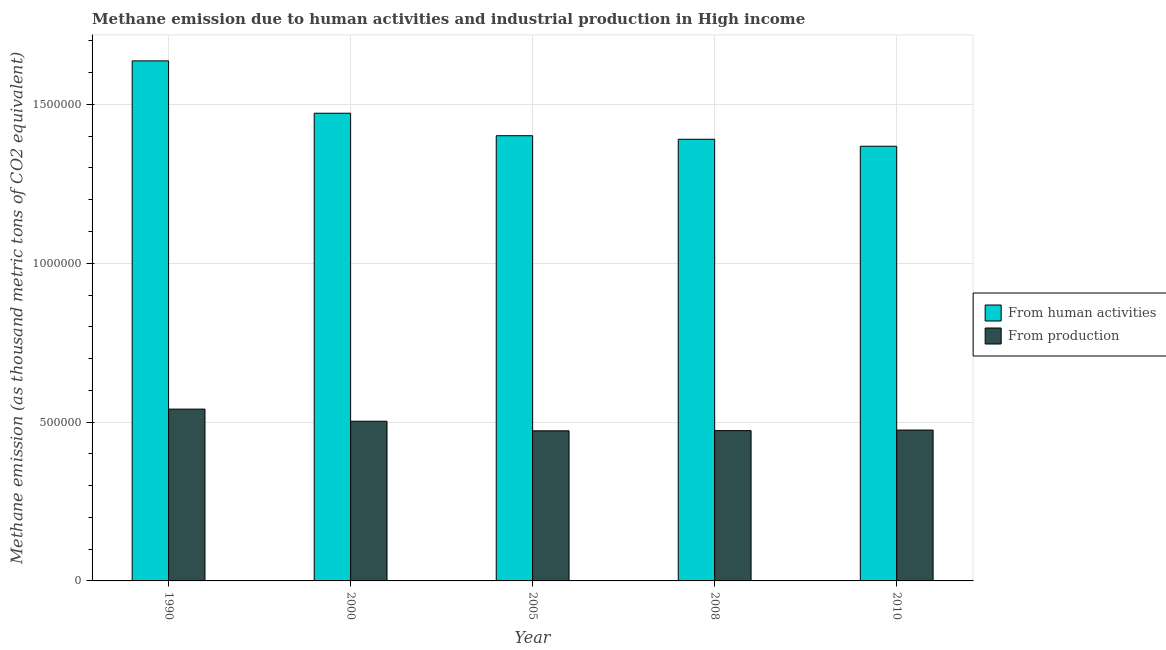How many different coloured bars are there?
Your answer should be very brief. 2. How many bars are there on the 5th tick from the left?
Offer a very short reply. 2. How many bars are there on the 2nd tick from the right?
Provide a succinct answer. 2. What is the amount of emissions generated from industries in 2010?
Keep it short and to the point. 4.75e+05. Across all years, what is the maximum amount of emissions generated from industries?
Give a very brief answer. 5.41e+05. Across all years, what is the minimum amount of emissions generated from industries?
Provide a succinct answer. 4.73e+05. In which year was the amount of emissions from human activities maximum?
Ensure brevity in your answer.  1990. What is the total amount of emissions from human activities in the graph?
Your answer should be compact. 7.27e+06. What is the difference between the amount of emissions from human activities in 2005 and that in 2010?
Your answer should be compact. 3.32e+04. What is the difference between the amount of emissions from human activities in 2005 and the amount of emissions generated from industries in 2008?
Ensure brevity in your answer.  1.12e+04. What is the average amount of emissions from human activities per year?
Give a very brief answer. 1.45e+06. In the year 2000, what is the difference between the amount of emissions generated from industries and amount of emissions from human activities?
Ensure brevity in your answer.  0. In how many years, is the amount of emissions from human activities greater than 300000 thousand metric tons?
Offer a terse response. 5. What is the ratio of the amount of emissions generated from industries in 1990 to that in 2000?
Make the answer very short. 1.08. Is the amount of emissions generated from industries in 1990 less than that in 2000?
Your response must be concise. No. What is the difference between the highest and the second highest amount of emissions generated from industries?
Provide a succinct answer. 3.82e+04. What is the difference between the highest and the lowest amount of emissions from human activities?
Your answer should be compact. 2.69e+05. In how many years, is the amount of emissions from human activities greater than the average amount of emissions from human activities taken over all years?
Give a very brief answer. 2. Is the sum of the amount of emissions from human activities in 2000 and 2008 greater than the maximum amount of emissions generated from industries across all years?
Your answer should be compact. Yes. What does the 2nd bar from the left in 2005 represents?
Offer a very short reply. From production. What does the 2nd bar from the right in 2005 represents?
Give a very brief answer. From human activities. How many bars are there?
Provide a short and direct response. 10. How many years are there in the graph?
Provide a short and direct response. 5. Are the values on the major ticks of Y-axis written in scientific E-notation?
Your answer should be compact. No. Does the graph contain grids?
Make the answer very short. Yes. Where does the legend appear in the graph?
Keep it short and to the point. Center right. How many legend labels are there?
Your response must be concise. 2. What is the title of the graph?
Offer a very short reply. Methane emission due to human activities and industrial production in High income. What is the label or title of the Y-axis?
Your response must be concise. Methane emission (as thousand metric tons of CO2 equivalent). What is the Methane emission (as thousand metric tons of CO2 equivalent) of From human activities in 1990?
Offer a terse response. 1.64e+06. What is the Methane emission (as thousand metric tons of CO2 equivalent) in From production in 1990?
Keep it short and to the point. 5.41e+05. What is the Methane emission (as thousand metric tons of CO2 equivalent) of From human activities in 2000?
Keep it short and to the point. 1.47e+06. What is the Methane emission (as thousand metric tons of CO2 equivalent) in From production in 2000?
Ensure brevity in your answer.  5.03e+05. What is the Methane emission (as thousand metric tons of CO2 equivalent) in From human activities in 2005?
Your response must be concise. 1.40e+06. What is the Methane emission (as thousand metric tons of CO2 equivalent) in From production in 2005?
Provide a short and direct response. 4.73e+05. What is the Methane emission (as thousand metric tons of CO2 equivalent) in From human activities in 2008?
Ensure brevity in your answer.  1.39e+06. What is the Methane emission (as thousand metric tons of CO2 equivalent) of From production in 2008?
Make the answer very short. 4.73e+05. What is the Methane emission (as thousand metric tons of CO2 equivalent) of From human activities in 2010?
Keep it short and to the point. 1.37e+06. What is the Methane emission (as thousand metric tons of CO2 equivalent) of From production in 2010?
Your answer should be very brief. 4.75e+05. Across all years, what is the maximum Methane emission (as thousand metric tons of CO2 equivalent) in From human activities?
Keep it short and to the point. 1.64e+06. Across all years, what is the maximum Methane emission (as thousand metric tons of CO2 equivalent) of From production?
Offer a terse response. 5.41e+05. Across all years, what is the minimum Methane emission (as thousand metric tons of CO2 equivalent) in From human activities?
Keep it short and to the point. 1.37e+06. Across all years, what is the minimum Methane emission (as thousand metric tons of CO2 equivalent) of From production?
Your answer should be compact. 4.73e+05. What is the total Methane emission (as thousand metric tons of CO2 equivalent) in From human activities in the graph?
Give a very brief answer. 7.27e+06. What is the total Methane emission (as thousand metric tons of CO2 equivalent) in From production in the graph?
Offer a terse response. 2.46e+06. What is the difference between the Methane emission (as thousand metric tons of CO2 equivalent) in From human activities in 1990 and that in 2000?
Make the answer very short. 1.65e+05. What is the difference between the Methane emission (as thousand metric tons of CO2 equivalent) in From production in 1990 and that in 2000?
Offer a very short reply. 3.82e+04. What is the difference between the Methane emission (as thousand metric tons of CO2 equivalent) of From human activities in 1990 and that in 2005?
Offer a very short reply. 2.36e+05. What is the difference between the Methane emission (as thousand metric tons of CO2 equivalent) of From production in 1990 and that in 2005?
Ensure brevity in your answer.  6.83e+04. What is the difference between the Methane emission (as thousand metric tons of CO2 equivalent) in From human activities in 1990 and that in 2008?
Provide a succinct answer. 2.47e+05. What is the difference between the Methane emission (as thousand metric tons of CO2 equivalent) in From production in 1990 and that in 2008?
Offer a terse response. 6.77e+04. What is the difference between the Methane emission (as thousand metric tons of CO2 equivalent) in From human activities in 1990 and that in 2010?
Provide a short and direct response. 2.69e+05. What is the difference between the Methane emission (as thousand metric tons of CO2 equivalent) in From production in 1990 and that in 2010?
Your answer should be compact. 6.59e+04. What is the difference between the Methane emission (as thousand metric tons of CO2 equivalent) of From human activities in 2000 and that in 2005?
Give a very brief answer. 7.08e+04. What is the difference between the Methane emission (as thousand metric tons of CO2 equivalent) of From production in 2000 and that in 2005?
Your answer should be compact. 3.02e+04. What is the difference between the Methane emission (as thousand metric tons of CO2 equivalent) of From human activities in 2000 and that in 2008?
Your response must be concise. 8.20e+04. What is the difference between the Methane emission (as thousand metric tons of CO2 equivalent) in From production in 2000 and that in 2008?
Provide a short and direct response. 2.96e+04. What is the difference between the Methane emission (as thousand metric tons of CO2 equivalent) of From human activities in 2000 and that in 2010?
Your answer should be very brief. 1.04e+05. What is the difference between the Methane emission (as thousand metric tons of CO2 equivalent) of From production in 2000 and that in 2010?
Your response must be concise. 2.78e+04. What is the difference between the Methane emission (as thousand metric tons of CO2 equivalent) in From human activities in 2005 and that in 2008?
Give a very brief answer. 1.12e+04. What is the difference between the Methane emission (as thousand metric tons of CO2 equivalent) in From production in 2005 and that in 2008?
Offer a terse response. -593. What is the difference between the Methane emission (as thousand metric tons of CO2 equivalent) of From human activities in 2005 and that in 2010?
Your answer should be very brief. 3.32e+04. What is the difference between the Methane emission (as thousand metric tons of CO2 equivalent) of From production in 2005 and that in 2010?
Give a very brief answer. -2407.6. What is the difference between the Methane emission (as thousand metric tons of CO2 equivalent) in From human activities in 2008 and that in 2010?
Provide a short and direct response. 2.20e+04. What is the difference between the Methane emission (as thousand metric tons of CO2 equivalent) in From production in 2008 and that in 2010?
Give a very brief answer. -1814.6. What is the difference between the Methane emission (as thousand metric tons of CO2 equivalent) of From human activities in 1990 and the Methane emission (as thousand metric tons of CO2 equivalent) of From production in 2000?
Offer a very short reply. 1.13e+06. What is the difference between the Methane emission (as thousand metric tons of CO2 equivalent) in From human activities in 1990 and the Methane emission (as thousand metric tons of CO2 equivalent) in From production in 2005?
Your response must be concise. 1.16e+06. What is the difference between the Methane emission (as thousand metric tons of CO2 equivalent) in From human activities in 1990 and the Methane emission (as thousand metric tons of CO2 equivalent) in From production in 2008?
Offer a terse response. 1.16e+06. What is the difference between the Methane emission (as thousand metric tons of CO2 equivalent) in From human activities in 1990 and the Methane emission (as thousand metric tons of CO2 equivalent) in From production in 2010?
Your response must be concise. 1.16e+06. What is the difference between the Methane emission (as thousand metric tons of CO2 equivalent) of From human activities in 2000 and the Methane emission (as thousand metric tons of CO2 equivalent) of From production in 2005?
Keep it short and to the point. 1.00e+06. What is the difference between the Methane emission (as thousand metric tons of CO2 equivalent) of From human activities in 2000 and the Methane emission (as thousand metric tons of CO2 equivalent) of From production in 2008?
Ensure brevity in your answer.  9.99e+05. What is the difference between the Methane emission (as thousand metric tons of CO2 equivalent) of From human activities in 2000 and the Methane emission (as thousand metric tons of CO2 equivalent) of From production in 2010?
Your answer should be very brief. 9.97e+05. What is the difference between the Methane emission (as thousand metric tons of CO2 equivalent) in From human activities in 2005 and the Methane emission (as thousand metric tons of CO2 equivalent) in From production in 2008?
Keep it short and to the point. 9.28e+05. What is the difference between the Methane emission (as thousand metric tons of CO2 equivalent) of From human activities in 2005 and the Methane emission (as thousand metric tons of CO2 equivalent) of From production in 2010?
Make the answer very short. 9.27e+05. What is the difference between the Methane emission (as thousand metric tons of CO2 equivalent) of From human activities in 2008 and the Methane emission (as thousand metric tons of CO2 equivalent) of From production in 2010?
Your response must be concise. 9.15e+05. What is the average Methane emission (as thousand metric tons of CO2 equivalent) of From human activities per year?
Provide a succinct answer. 1.45e+06. What is the average Methane emission (as thousand metric tons of CO2 equivalent) in From production per year?
Give a very brief answer. 4.93e+05. In the year 1990, what is the difference between the Methane emission (as thousand metric tons of CO2 equivalent) in From human activities and Methane emission (as thousand metric tons of CO2 equivalent) in From production?
Provide a succinct answer. 1.10e+06. In the year 2000, what is the difference between the Methane emission (as thousand metric tons of CO2 equivalent) in From human activities and Methane emission (as thousand metric tons of CO2 equivalent) in From production?
Your response must be concise. 9.70e+05. In the year 2005, what is the difference between the Methane emission (as thousand metric tons of CO2 equivalent) in From human activities and Methane emission (as thousand metric tons of CO2 equivalent) in From production?
Offer a terse response. 9.29e+05. In the year 2008, what is the difference between the Methane emission (as thousand metric tons of CO2 equivalent) of From human activities and Methane emission (as thousand metric tons of CO2 equivalent) of From production?
Offer a terse response. 9.17e+05. In the year 2010, what is the difference between the Methane emission (as thousand metric tons of CO2 equivalent) in From human activities and Methane emission (as thousand metric tons of CO2 equivalent) in From production?
Provide a succinct answer. 8.93e+05. What is the ratio of the Methane emission (as thousand metric tons of CO2 equivalent) in From human activities in 1990 to that in 2000?
Offer a very short reply. 1.11. What is the ratio of the Methane emission (as thousand metric tons of CO2 equivalent) of From production in 1990 to that in 2000?
Offer a terse response. 1.08. What is the ratio of the Methane emission (as thousand metric tons of CO2 equivalent) in From human activities in 1990 to that in 2005?
Provide a short and direct response. 1.17. What is the ratio of the Methane emission (as thousand metric tons of CO2 equivalent) in From production in 1990 to that in 2005?
Keep it short and to the point. 1.14. What is the ratio of the Methane emission (as thousand metric tons of CO2 equivalent) of From human activities in 1990 to that in 2008?
Your answer should be compact. 1.18. What is the ratio of the Methane emission (as thousand metric tons of CO2 equivalent) in From production in 1990 to that in 2008?
Your answer should be compact. 1.14. What is the ratio of the Methane emission (as thousand metric tons of CO2 equivalent) of From human activities in 1990 to that in 2010?
Provide a short and direct response. 1.2. What is the ratio of the Methane emission (as thousand metric tons of CO2 equivalent) in From production in 1990 to that in 2010?
Give a very brief answer. 1.14. What is the ratio of the Methane emission (as thousand metric tons of CO2 equivalent) of From human activities in 2000 to that in 2005?
Provide a short and direct response. 1.05. What is the ratio of the Methane emission (as thousand metric tons of CO2 equivalent) of From production in 2000 to that in 2005?
Offer a terse response. 1.06. What is the ratio of the Methane emission (as thousand metric tons of CO2 equivalent) in From human activities in 2000 to that in 2008?
Offer a very short reply. 1.06. What is the ratio of the Methane emission (as thousand metric tons of CO2 equivalent) of From production in 2000 to that in 2008?
Make the answer very short. 1.06. What is the ratio of the Methane emission (as thousand metric tons of CO2 equivalent) in From human activities in 2000 to that in 2010?
Keep it short and to the point. 1.08. What is the ratio of the Methane emission (as thousand metric tons of CO2 equivalent) in From production in 2000 to that in 2010?
Give a very brief answer. 1.06. What is the ratio of the Methane emission (as thousand metric tons of CO2 equivalent) in From human activities in 2005 to that in 2008?
Give a very brief answer. 1.01. What is the ratio of the Methane emission (as thousand metric tons of CO2 equivalent) of From production in 2005 to that in 2008?
Offer a terse response. 1. What is the ratio of the Methane emission (as thousand metric tons of CO2 equivalent) in From human activities in 2005 to that in 2010?
Give a very brief answer. 1.02. What is the ratio of the Methane emission (as thousand metric tons of CO2 equivalent) of From human activities in 2008 to that in 2010?
Your answer should be compact. 1.02. What is the ratio of the Methane emission (as thousand metric tons of CO2 equivalent) of From production in 2008 to that in 2010?
Ensure brevity in your answer.  1. What is the difference between the highest and the second highest Methane emission (as thousand metric tons of CO2 equivalent) in From human activities?
Offer a very short reply. 1.65e+05. What is the difference between the highest and the second highest Methane emission (as thousand metric tons of CO2 equivalent) of From production?
Give a very brief answer. 3.82e+04. What is the difference between the highest and the lowest Methane emission (as thousand metric tons of CO2 equivalent) in From human activities?
Provide a succinct answer. 2.69e+05. What is the difference between the highest and the lowest Methane emission (as thousand metric tons of CO2 equivalent) of From production?
Your answer should be very brief. 6.83e+04. 